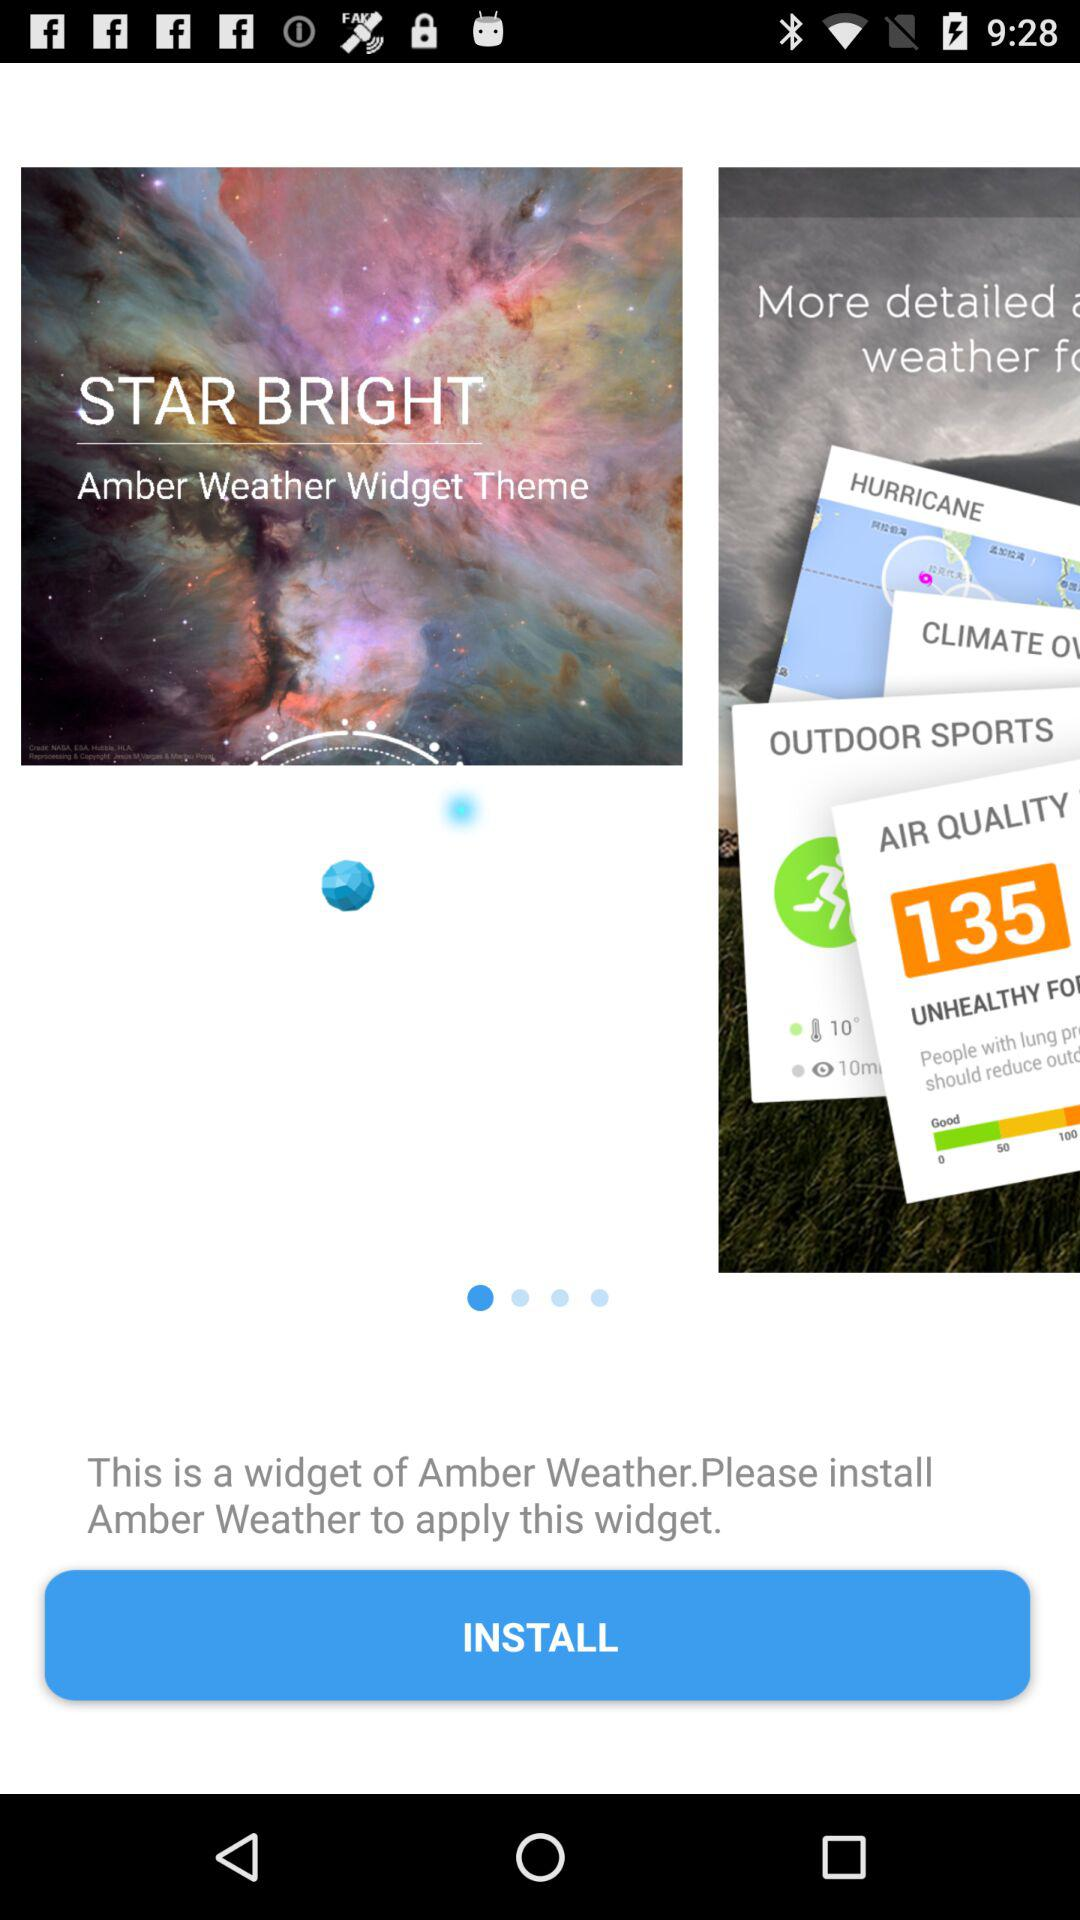Which application do we have to install to apply the widget? You have to install "Amber Weather" to apply the widget. 